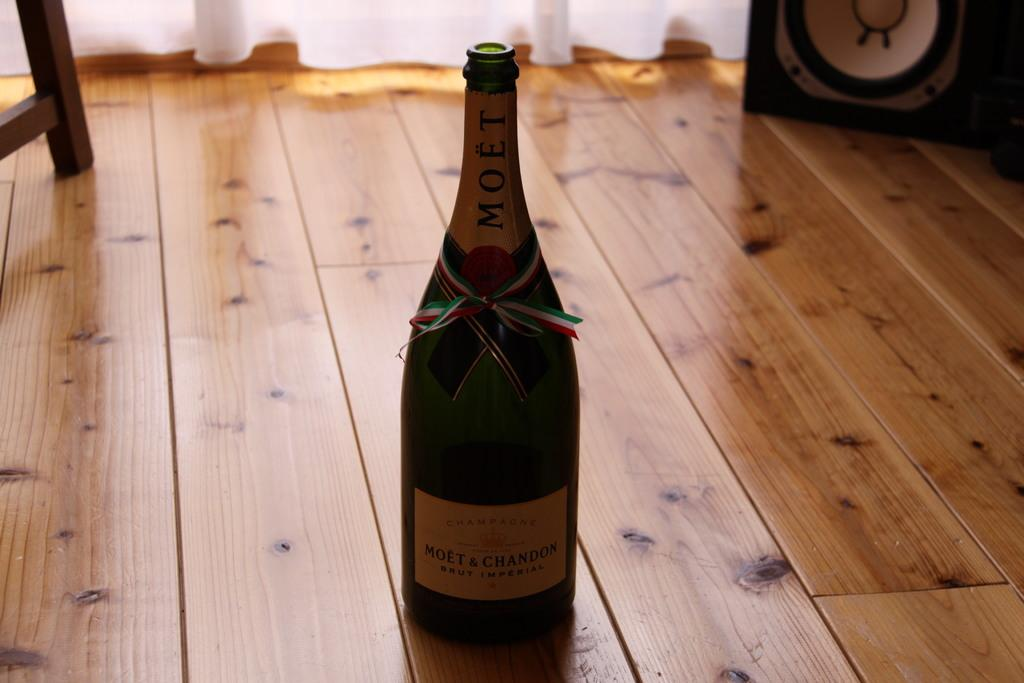<image>
Present a compact description of the photo's key features. A bottle of Moet with a ribbon around it sits on a wooden floor 